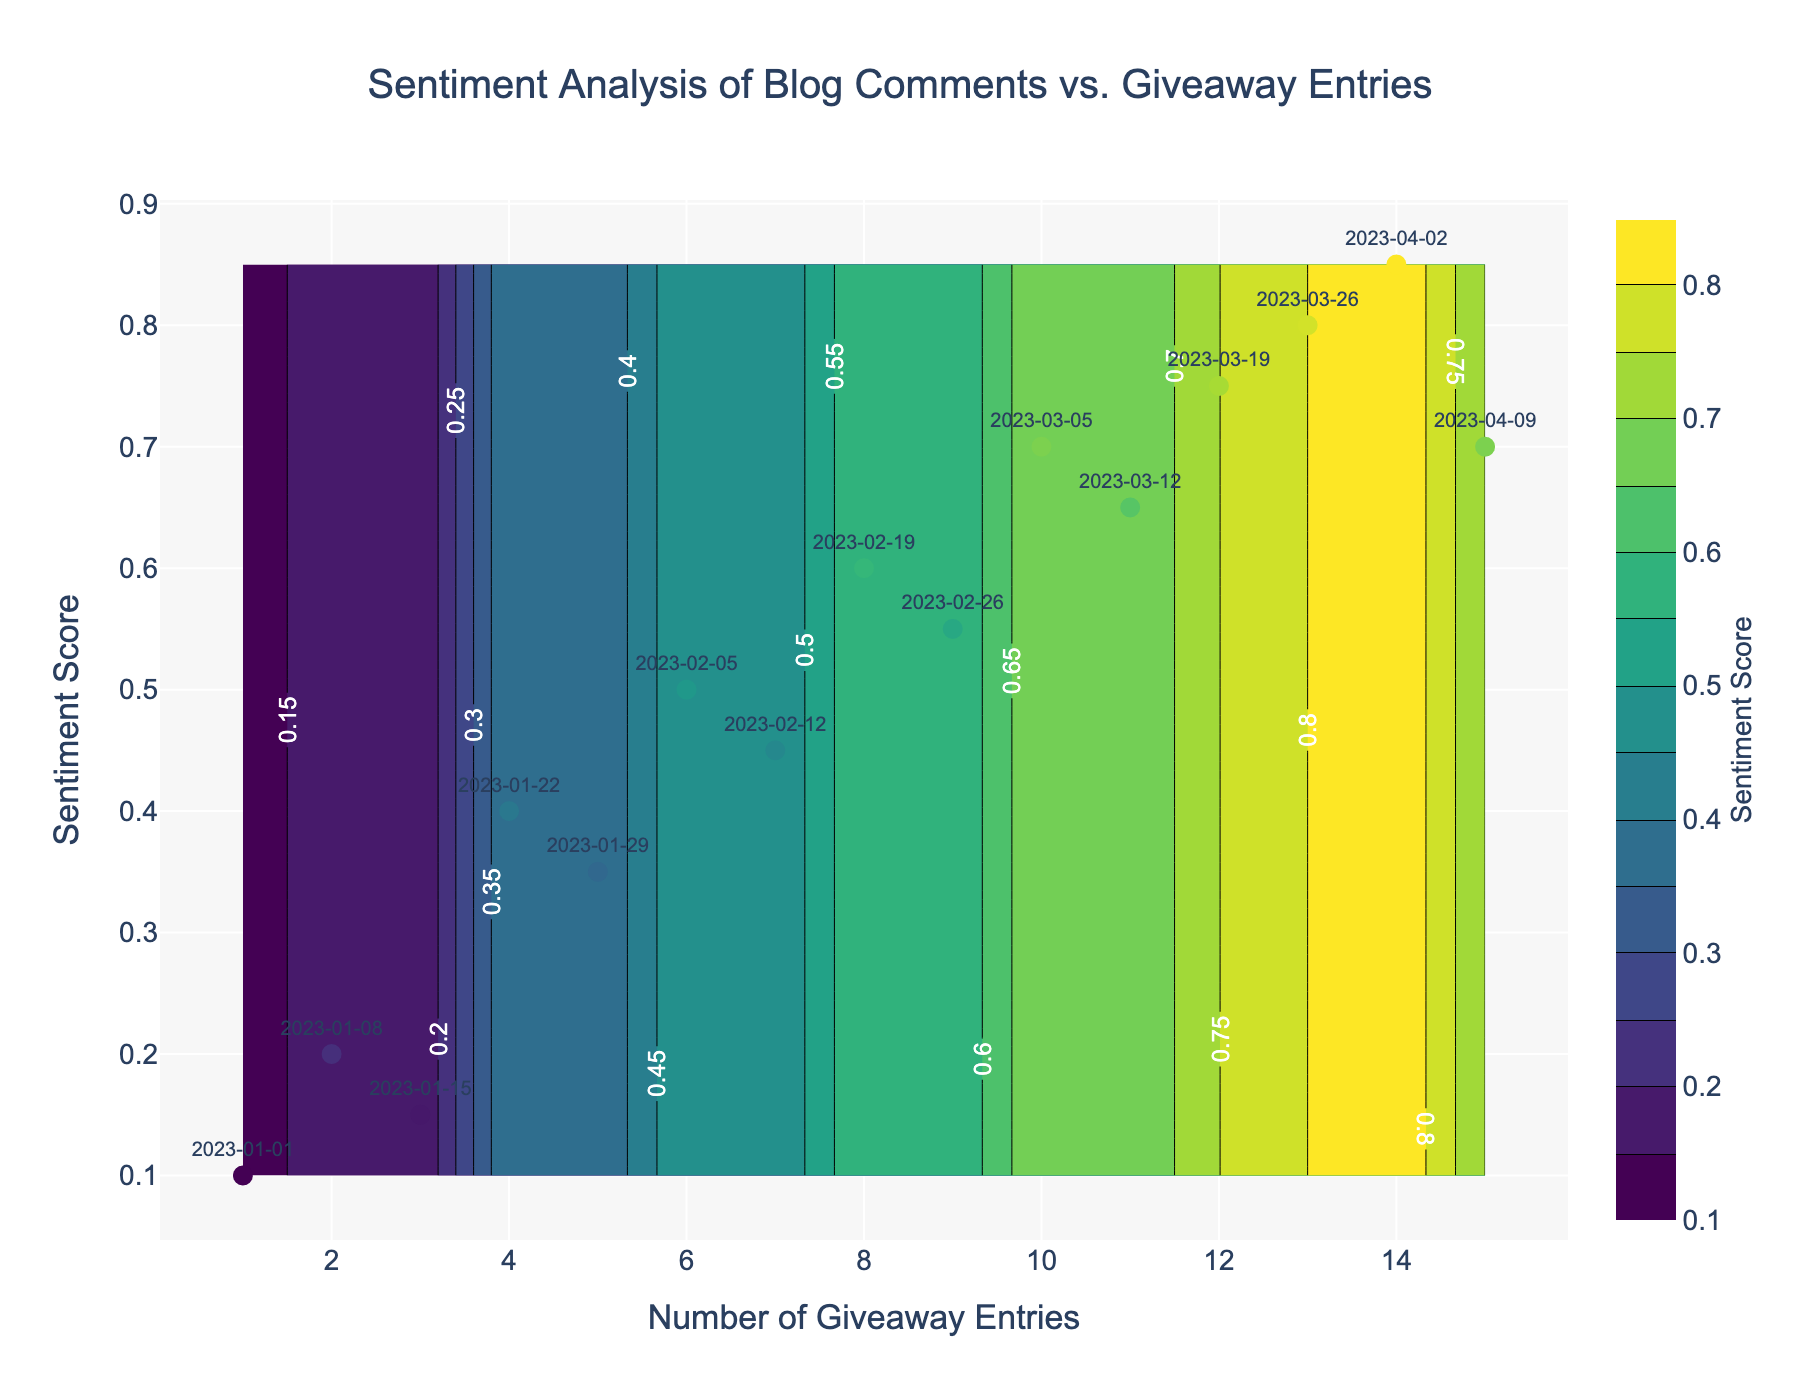What is the title of the figure? The title of the figure is located at the top center of the plot. It provides a summary of what the figure represents.
Answer: Sentiment Analysis of Blog Comments vs. Giveaway Entries How many data points are marked as scatter points? The scatter plot shows individual data points marked with markers. Each data point corresponds to a date, which is also labeled on the plot.
Answer: 15 What is the sentiment score on the date 2023-03-26? Locate the date 2023-03-26 on the scatter plot. The sentiment score for this date is the y-coordinate of the corresponding data point.
Answer: 0.8 Which date has the highest sentiment score and what is it? Identify the data point on the scatter plot with the highest y-coordinate (sentiment score). Then, read the date label of this data point.
Answer: 2023-04-02, 0.85 How does the sentiment score change as the number of giveaway entries increases? Observe the scatter plot and contour lines. Generally, the sentiment score increases as the number of giveaway entries increases. Evaluate the slope of the trend.
Answer: Increases What is the average sentiment score for entries with 5 or more giveaway entries? Find the data points with entry_count >= 5. Calculate the average of their sentiment scores. (0.35+0.5+0.45+0.6+0.55+0.7+0.65+0.75+0.8+0.85+0.7) / 11
Answer: 0.6336 Compare the sentiment scores for entry count 3 and entry count 10. Which one is higher? Find the sentiment scores for entry counts 3 and 10 from the scatter plot. Compare these values to determine which is higher.
Answer: Entry count 10 has a higher sentiment score (0.7 vs. 0.15) What sentiment score range corresponds to the most densely contoured area? Observe the contour plot and determine the region where the contour lines are closest. This is the area with the highest density. Read the y-axis values corresponding to this region.
Answer: 0.6 to 0.85 How many significant peaks can you identify from the contour plot? Examine the contour plot and identify the distinct areas where the contour lines form peaks. Count these areas.
Answer: 2 Which week experienced the most significant change in sentiment score? Compare the differences in sentiment scores between consecutive weeks. Identify the pair of weeks with the largest change in sentiment score.
Answer: 2023-01-15 to 2023-01-22 (0.15 to 0.4) 